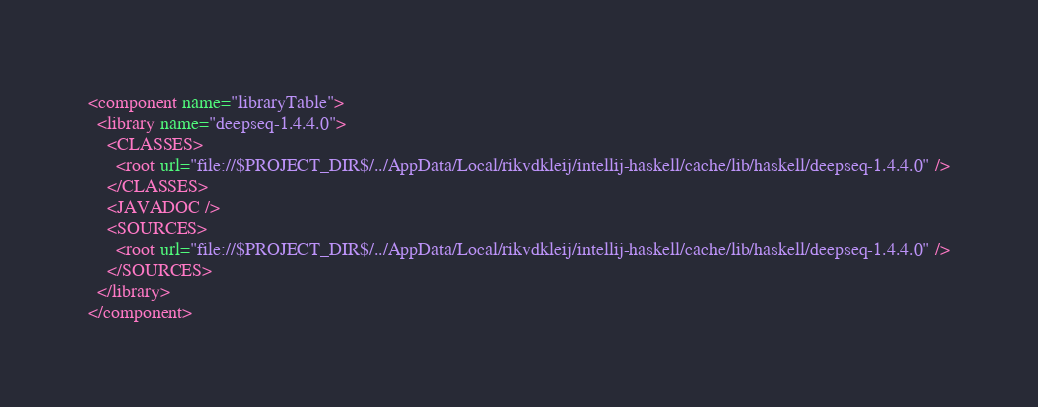<code> <loc_0><loc_0><loc_500><loc_500><_XML_><component name="libraryTable">
  <library name="deepseq-1.4.4.0">
    <CLASSES>
      <root url="file://$PROJECT_DIR$/../AppData/Local/rikvdkleij/intellij-haskell/cache/lib/haskell/deepseq-1.4.4.0" />
    </CLASSES>
    <JAVADOC />
    <SOURCES>
      <root url="file://$PROJECT_DIR$/../AppData/Local/rikvdkleij/intellij-haskell/cache/lib/haskell/deepseq-1.4.4.0" />
    </SOURCES>
  </library>
</component></code> 